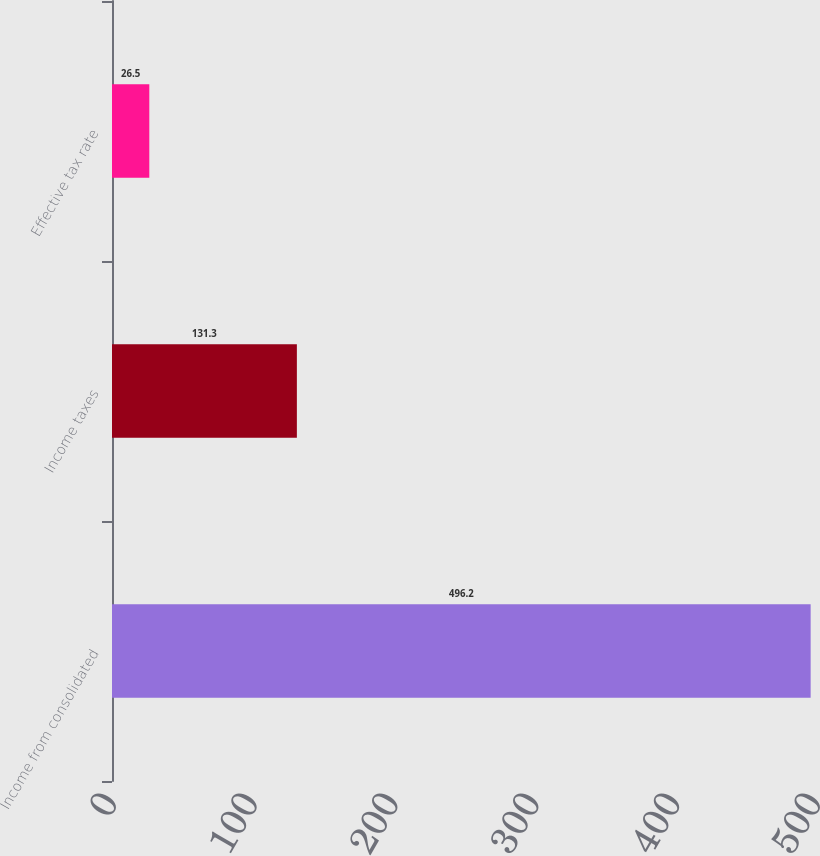Convert chart to OTSL. <chart><loc_0><loc_0><loc_500><loc_500><bar_chart><fcel>Income from consolidated<fcel>Income taxes<fcel>Effective tax rate<nl><fcel>496.2<fcel>131.3<fcel>26.5<nl></chart> 